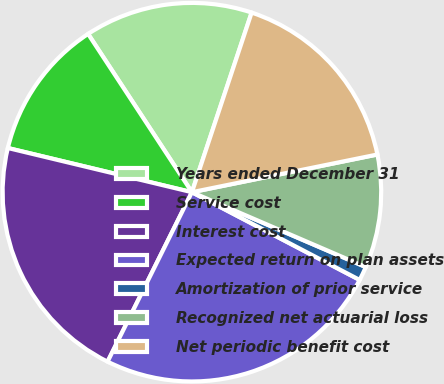Convert chart. <chart><loc_0><loc_0><loc_500><loc_500><pie_chart><fcel>Years ended December 31<fcel>Service cost<fcel>Interest cost<fcel>Expected return on plan assets<fcel>Amortization of prior service<fcel>Recognized net actuarial loss<fcel>Net periodic benefit cost<nl><fcel>14.35%<fcel>12.01%<fcel>21.4%<fcel>24.68%<fcel>1.2%<fcel>9.66%<fcel>16.7%<nl></chart> 